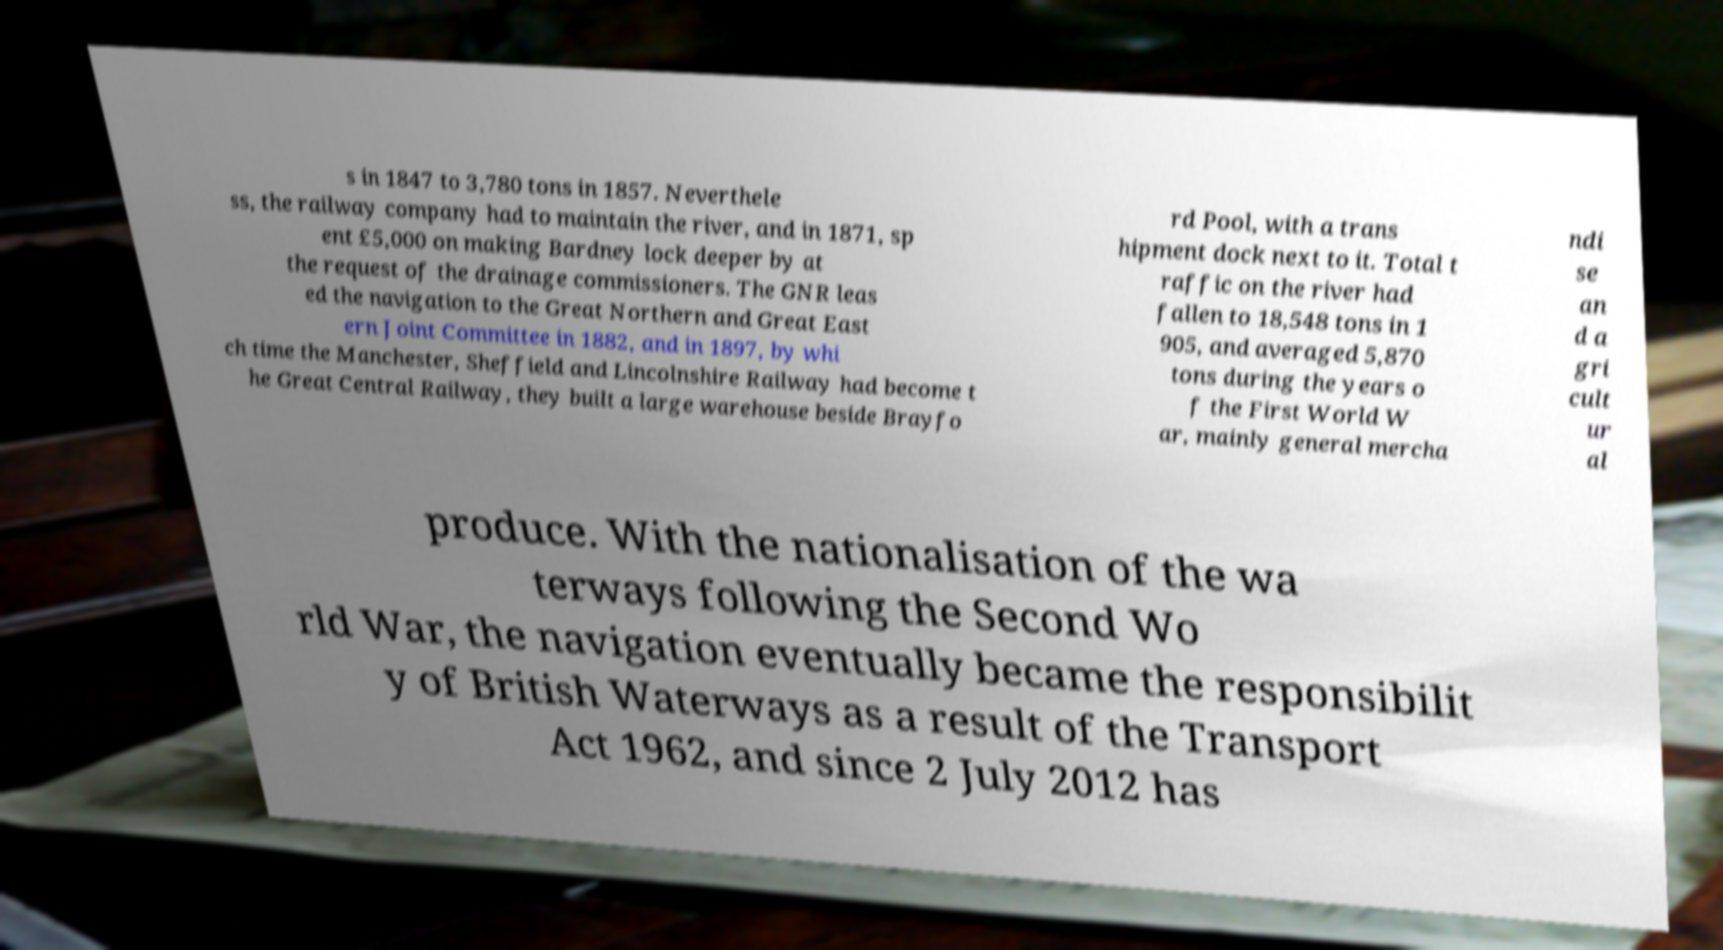I need the written content from this picture converted into text. Can you do that? s in 1847 to 3,780 tons in 1857. Neverthele ss, the railway company had to maintain the river, and in 1871, sp ent £5,000 on making Bardney lock deeper by at the request of the drainage commissioners. The GNR leas ed the navigation to the Great Northern and Great East ern Joint Committee in 1882, and in 1897, by whi ch time the Manchester, Sheffield and Lincolnshire Railway had become t he Great Central Railway, they built a large warehouse beside Brayfo rd Pool, with a trans hipment dock next to it. Total t raffic on the river had fallen to 18,548 tons in 1 905, and averaged 5,870 tons during the years o f the First World W ar, mainly general mercha ndi se an d a gri cult ur al produce. With the nationalisation of the wa terways following the Second Wo rld War, the navigation eventually became the responsibilit y of British Waterways as a result of the Transport Act 1962, and since 2 July 2012 has 